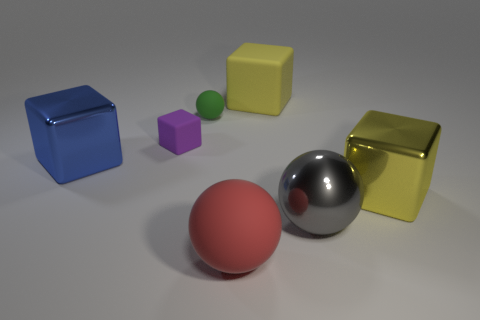Add 2 small red matte balls. How many objects exist? 9 Subtract all big blocks. How many blocks are left? 1 Subtract all red balls. How many balls are left? 2 Subtract all gray spheres. How many yellow blocks are left? 2 Subtract all blocks. How many objects are left? 3 Subtract all tiny green spheres. Subtract all tiny green objects. How many objects are left? 5 Add 4 metal balls. How many metal balls are left? 5 Add 7 large balls. How many large balls exist? 9 Subtract 0 brown balls. How many objects are left? 7 Subtract 2 spheres. How many spheres are left? 1 